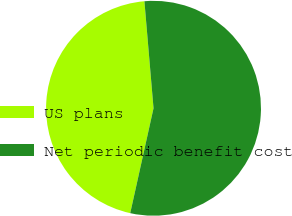Convert chart to OTSL. <chart><loc_0><loc_0><loc_500><loc_500><pie_chart><fcel>US plans<fcel>Net periodic benefit cost<nl><fcel>45.17%<fcel>54.83%<nl></chart> 